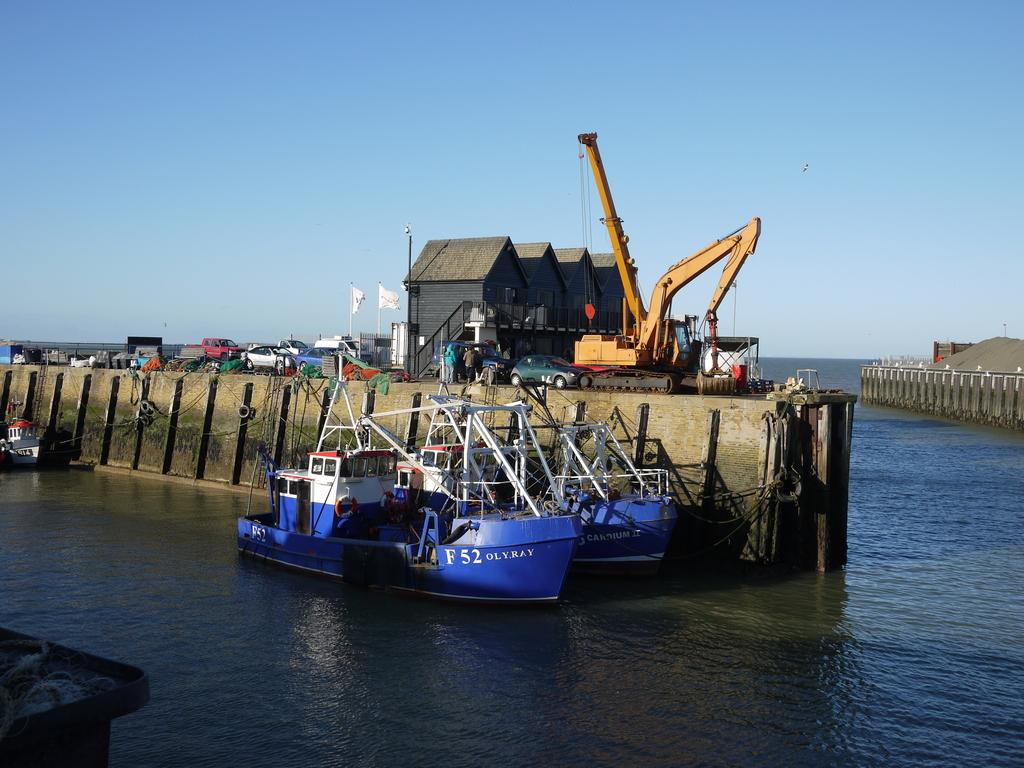What is on the water in the image? There are boats on the water in the image. What can be seen in the background of the image? In the background of the image, there are cars, persons standing, flags, a house, and a crane. How many different types of vehicles are visible in the image? There are two types of vehicles visible in the image: boats on the water and cars in the background. How many parts of a snake can be seen in the image? There are no snakes present in the image, so it is not possible to see any parts of a snake. 